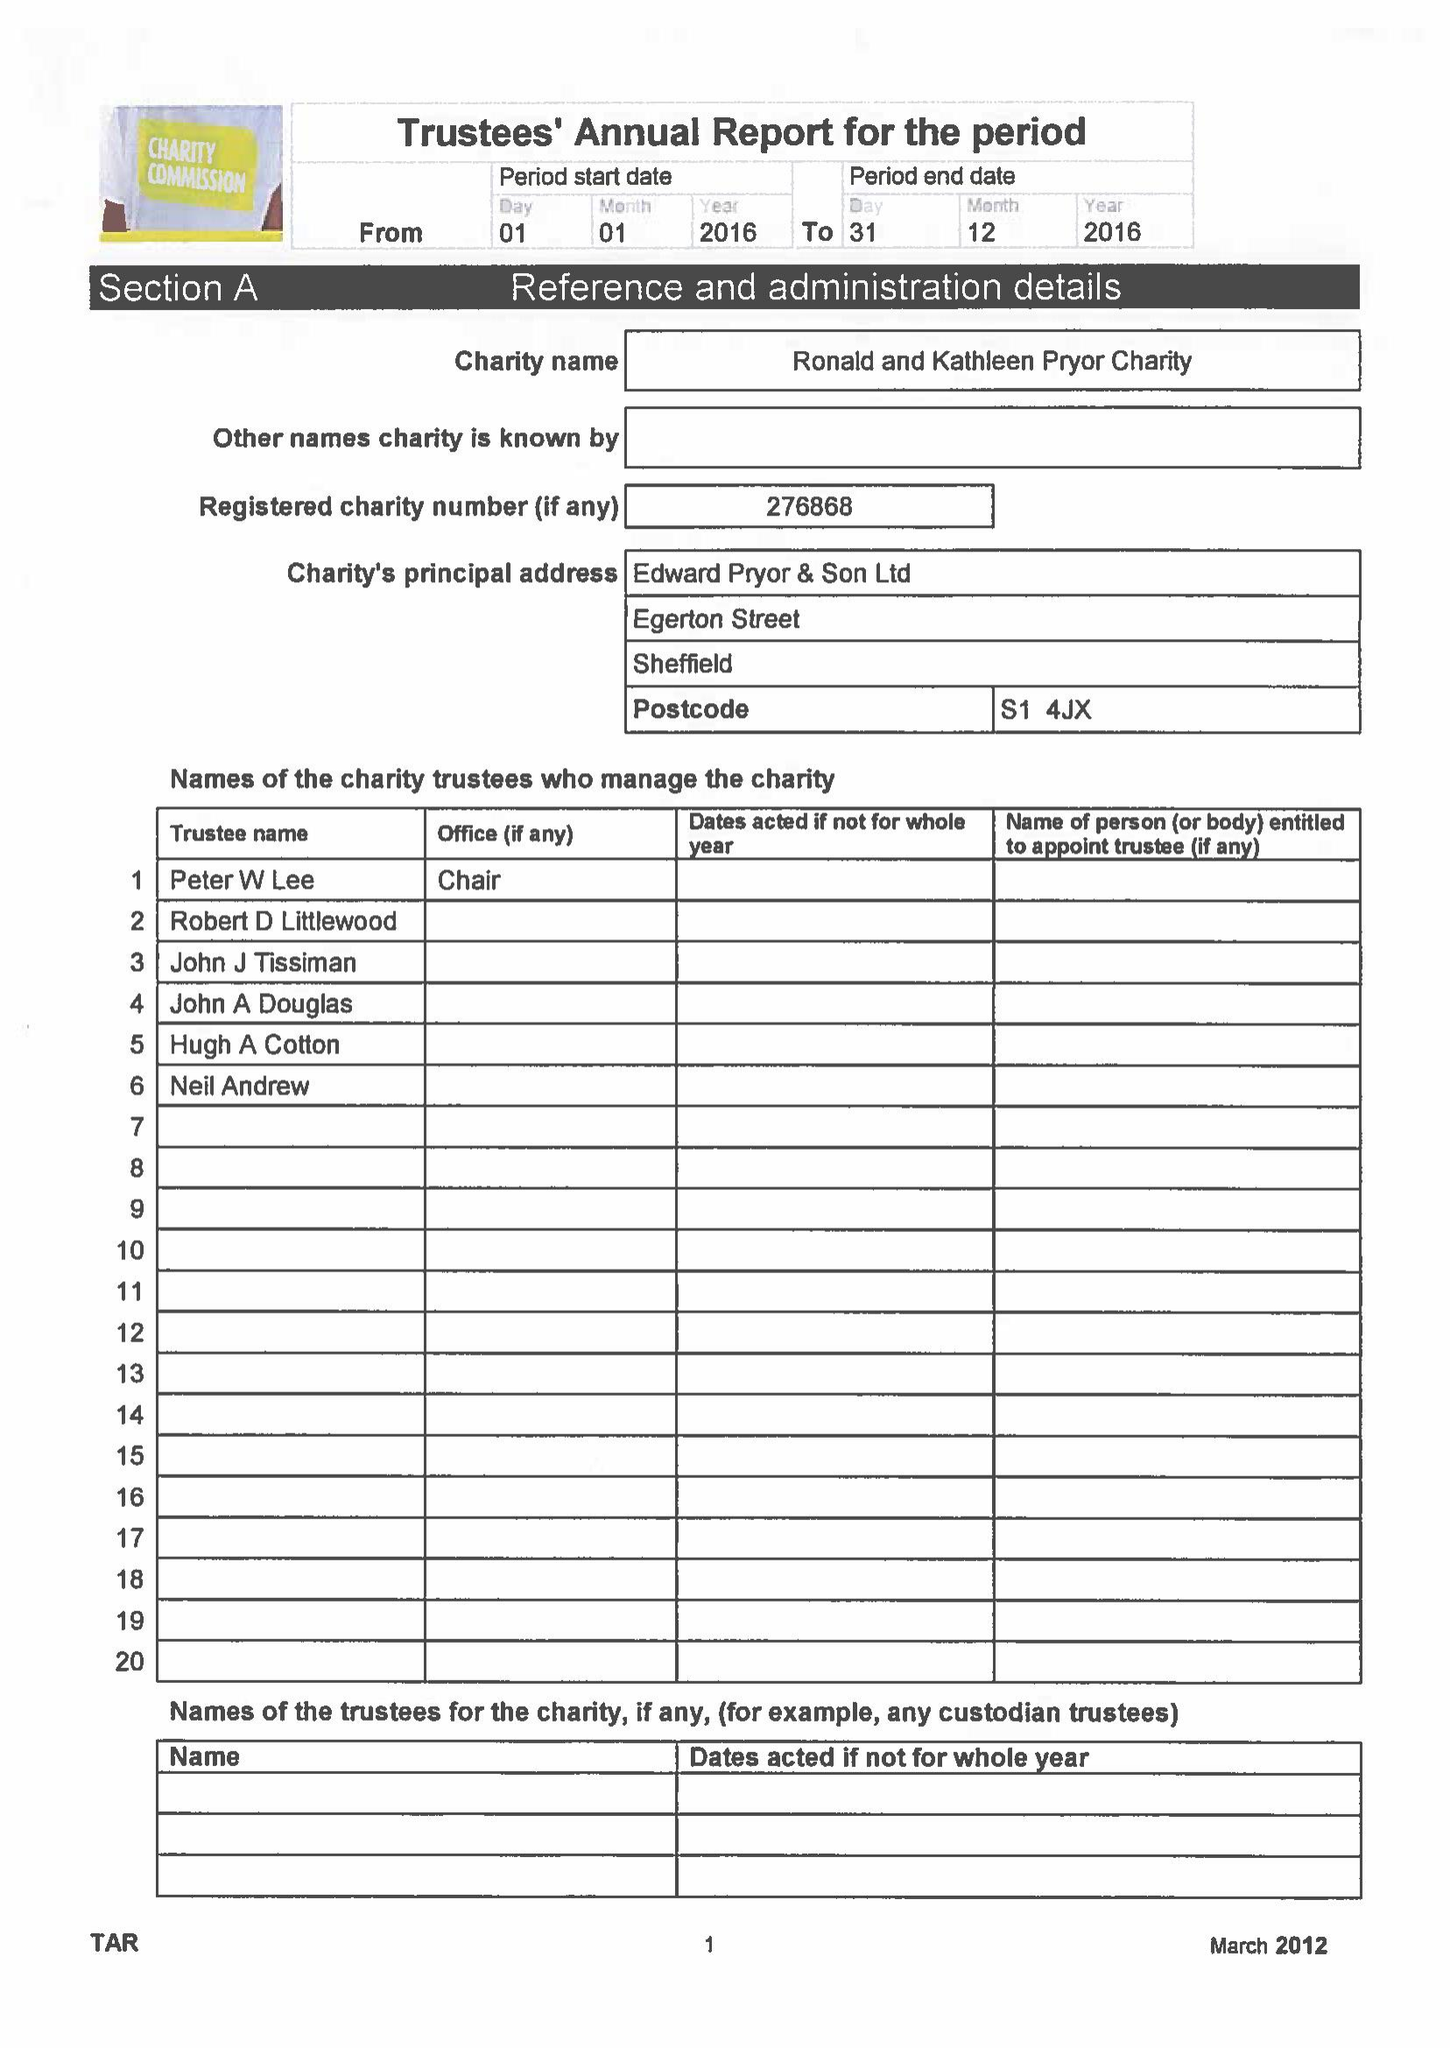What is the value for the charity_name?
Answer the question using a single word or phrase. The Ronald and Kathleen Pryor Charity 